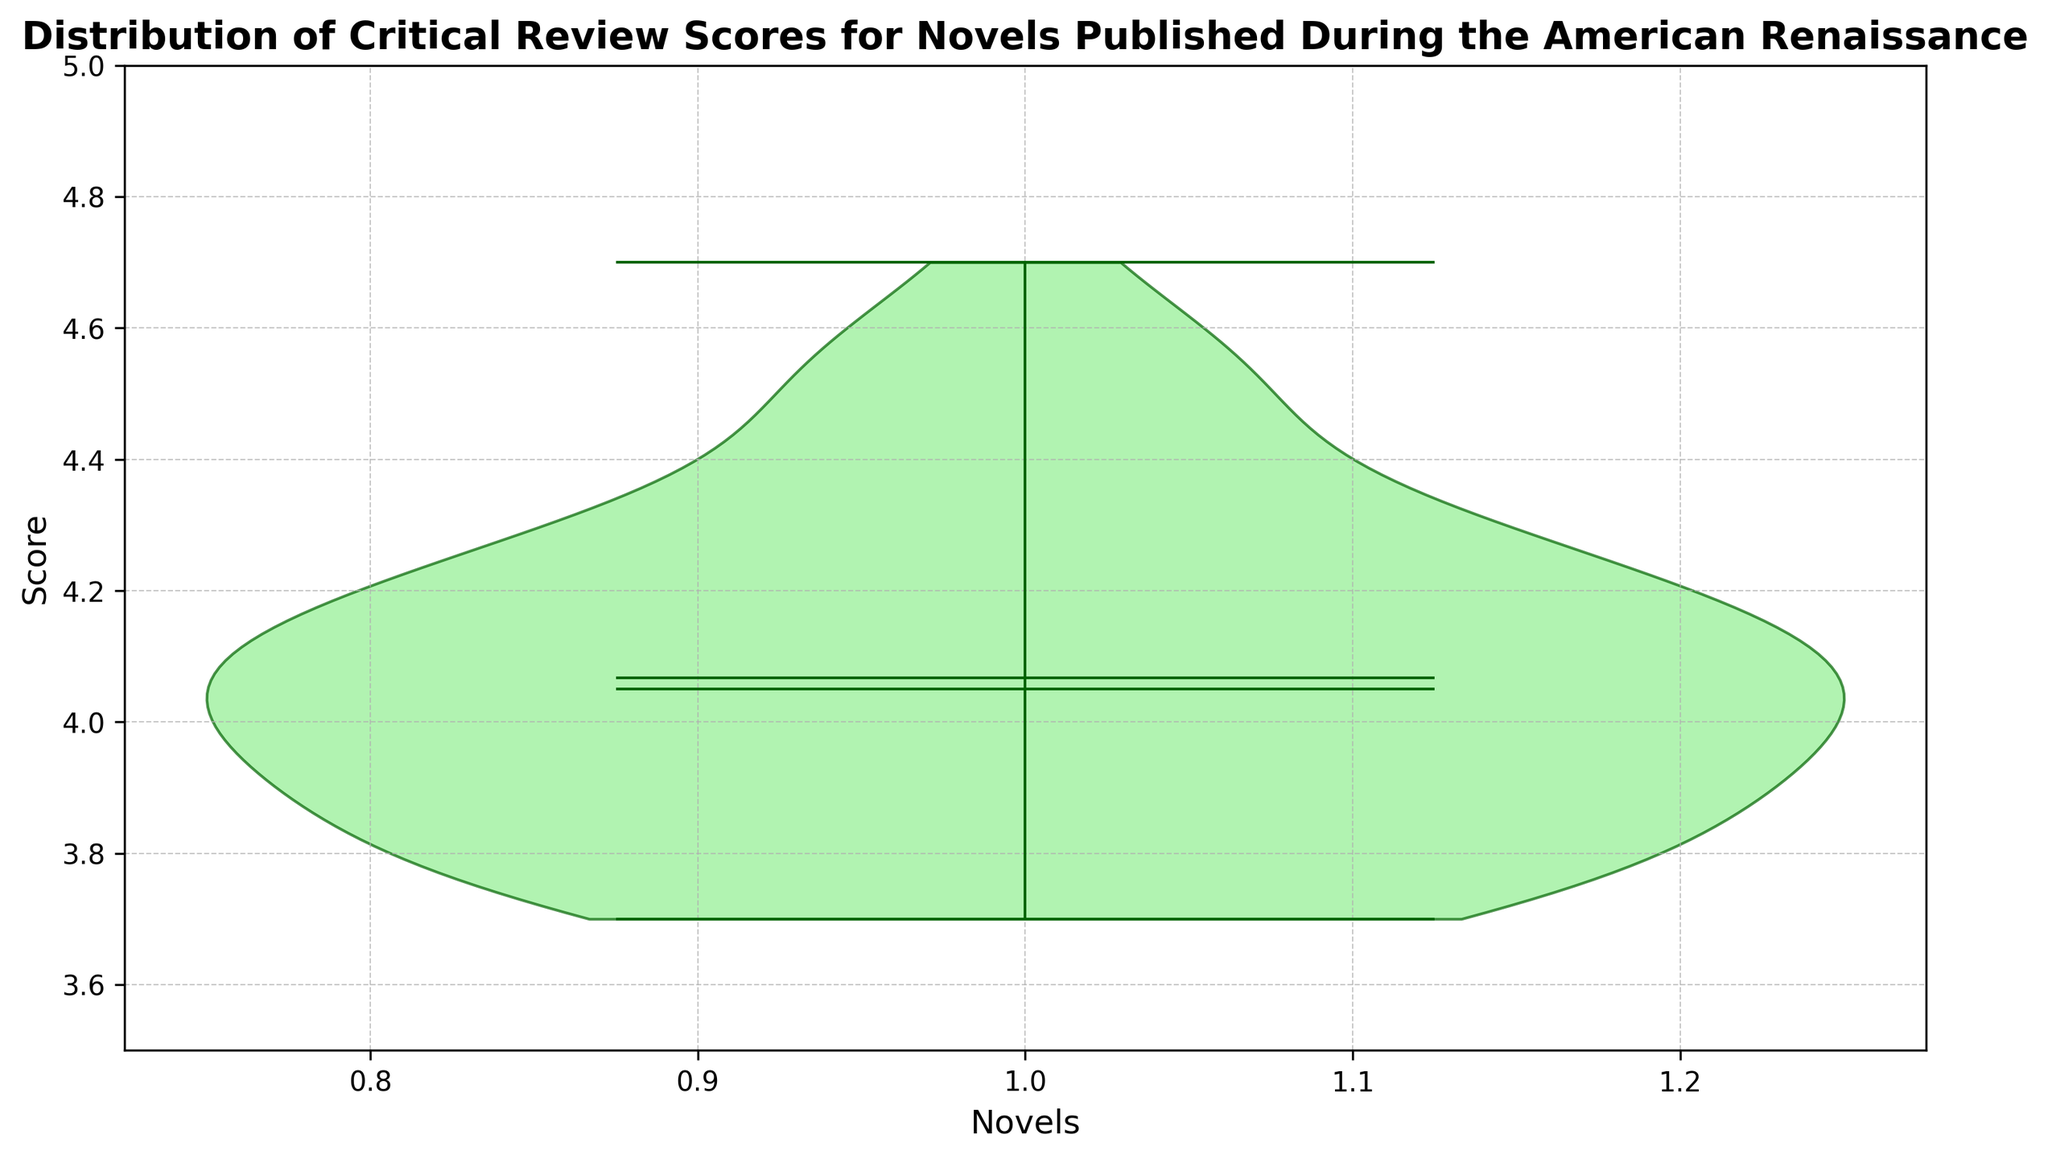How is the distribution of scores centered around the mean? The plot shows the mean as a white dot in the middle of the violin plot. If the violin shape is symmetric around this dot, the distribution is centered around the mean.
Answer: The distribution is centered around the mean What is the median score of the distribution? The median is shown as a horizontal line within the violin plot. Identify this line and read its corresponding value on the y-axis.
Answer: 4.1 What is the range of scores represented in the plot? The range is the difference between the maximum and minimum values. These are indicated by the ends of the whiskers in the violin plot.
Answer: 3.7 to 4.7 Are the scores more tightly clustered around the median or the mean? Evaluate the concentration of data points indicated by the width of the violin plot around the median and the mean. If the plot is wider at the mean or median, more data points are concentrated there.
Answer: Around the median What is the interquartile range (IQR) of the scores? The IQR can be identified if the violin plot shows quartiles (though these are not displayed in this violin plot). Instead, we can estimate it based on the density of the plot near the narrower middle range.
Answer: Approximately between 3.9 and 4.3 How does the spread of the data above the mean compare to the spread below the mean? Compare the width and length of the violin plot above and below the mean marker.
Answer: The spread is somewhat symmetrical around the mean Does the plot indicate the presence of any outliers? Outliers would appear as individual points outside the main body of the violin plot. Check for any such points in the plot.
Answer: No outliers Is there any skewness in the distribution of scores? Skewness can be identified by checking if one tail of the violin plot is longer than the other.
Answer: Slightly skewed right What scores have the highest density of reviews? Identify the widest sections of the violin plot as these represent the highest density of data points.
Answer: Around 4.1 Comparing the mean and median, which measures the central tendency more accurately in this plot? Assess both the mean and median values and check for any significant difference. If they are close, either measure may be accurate. If not, explain the reasoning.
Answer: Median, since it better represents the central clustering of scores 